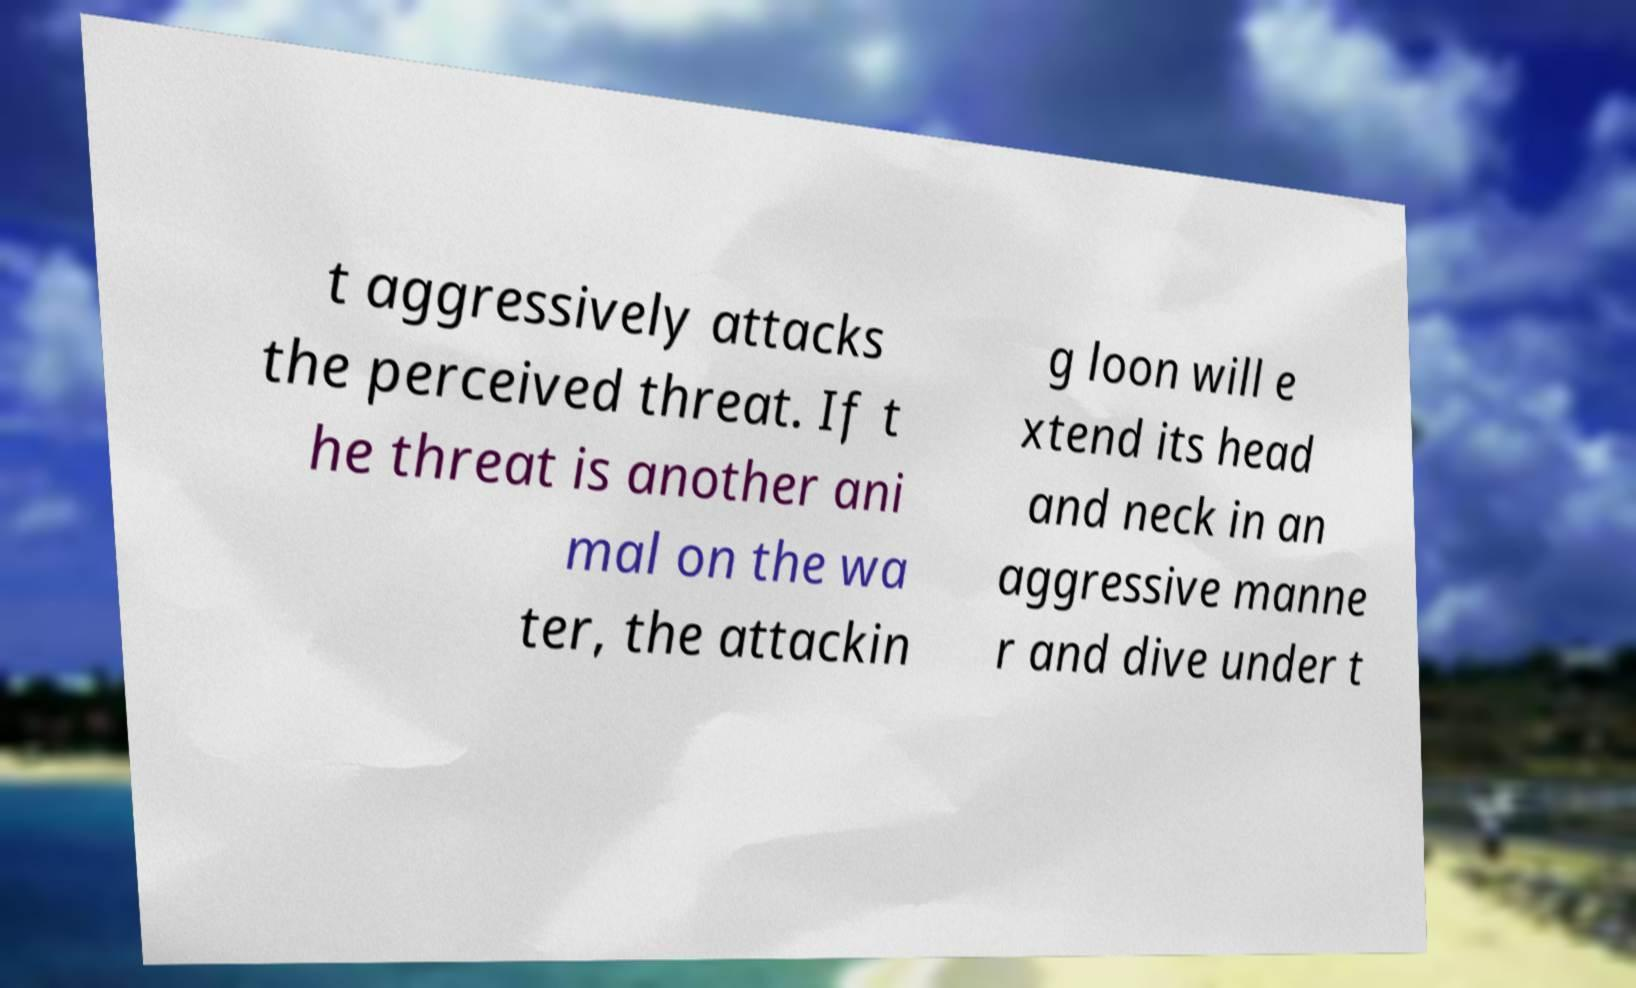Could you assist in decoding the text presented in this image and type it out clearly? t aggressively attacks the perceived threat. If t he threat is another ani mal on the wa ter, the attackin g loon will e xtend its head and neck in an aggressive manne r and dive under t 